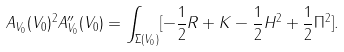Convert formula to latex. <formula><loc_0><loc_0><loc_500><loc_500>A _ { V _ { 0 } } ( V _ { 0 } ) ^ { 2 } A _ { V _ { 0 } } ^ { \prime \prime } ( V _ { 0 } ) = \int _ { \Sigma ( V _ { 0 } ) } [ - \frac { 1 } { 2 } R + K - \frac { 1 } { 2 } H ^ { 2 } + \frac { 1 } { 2 } \| \Pi \| ^ { 2 } ] .</formula> 